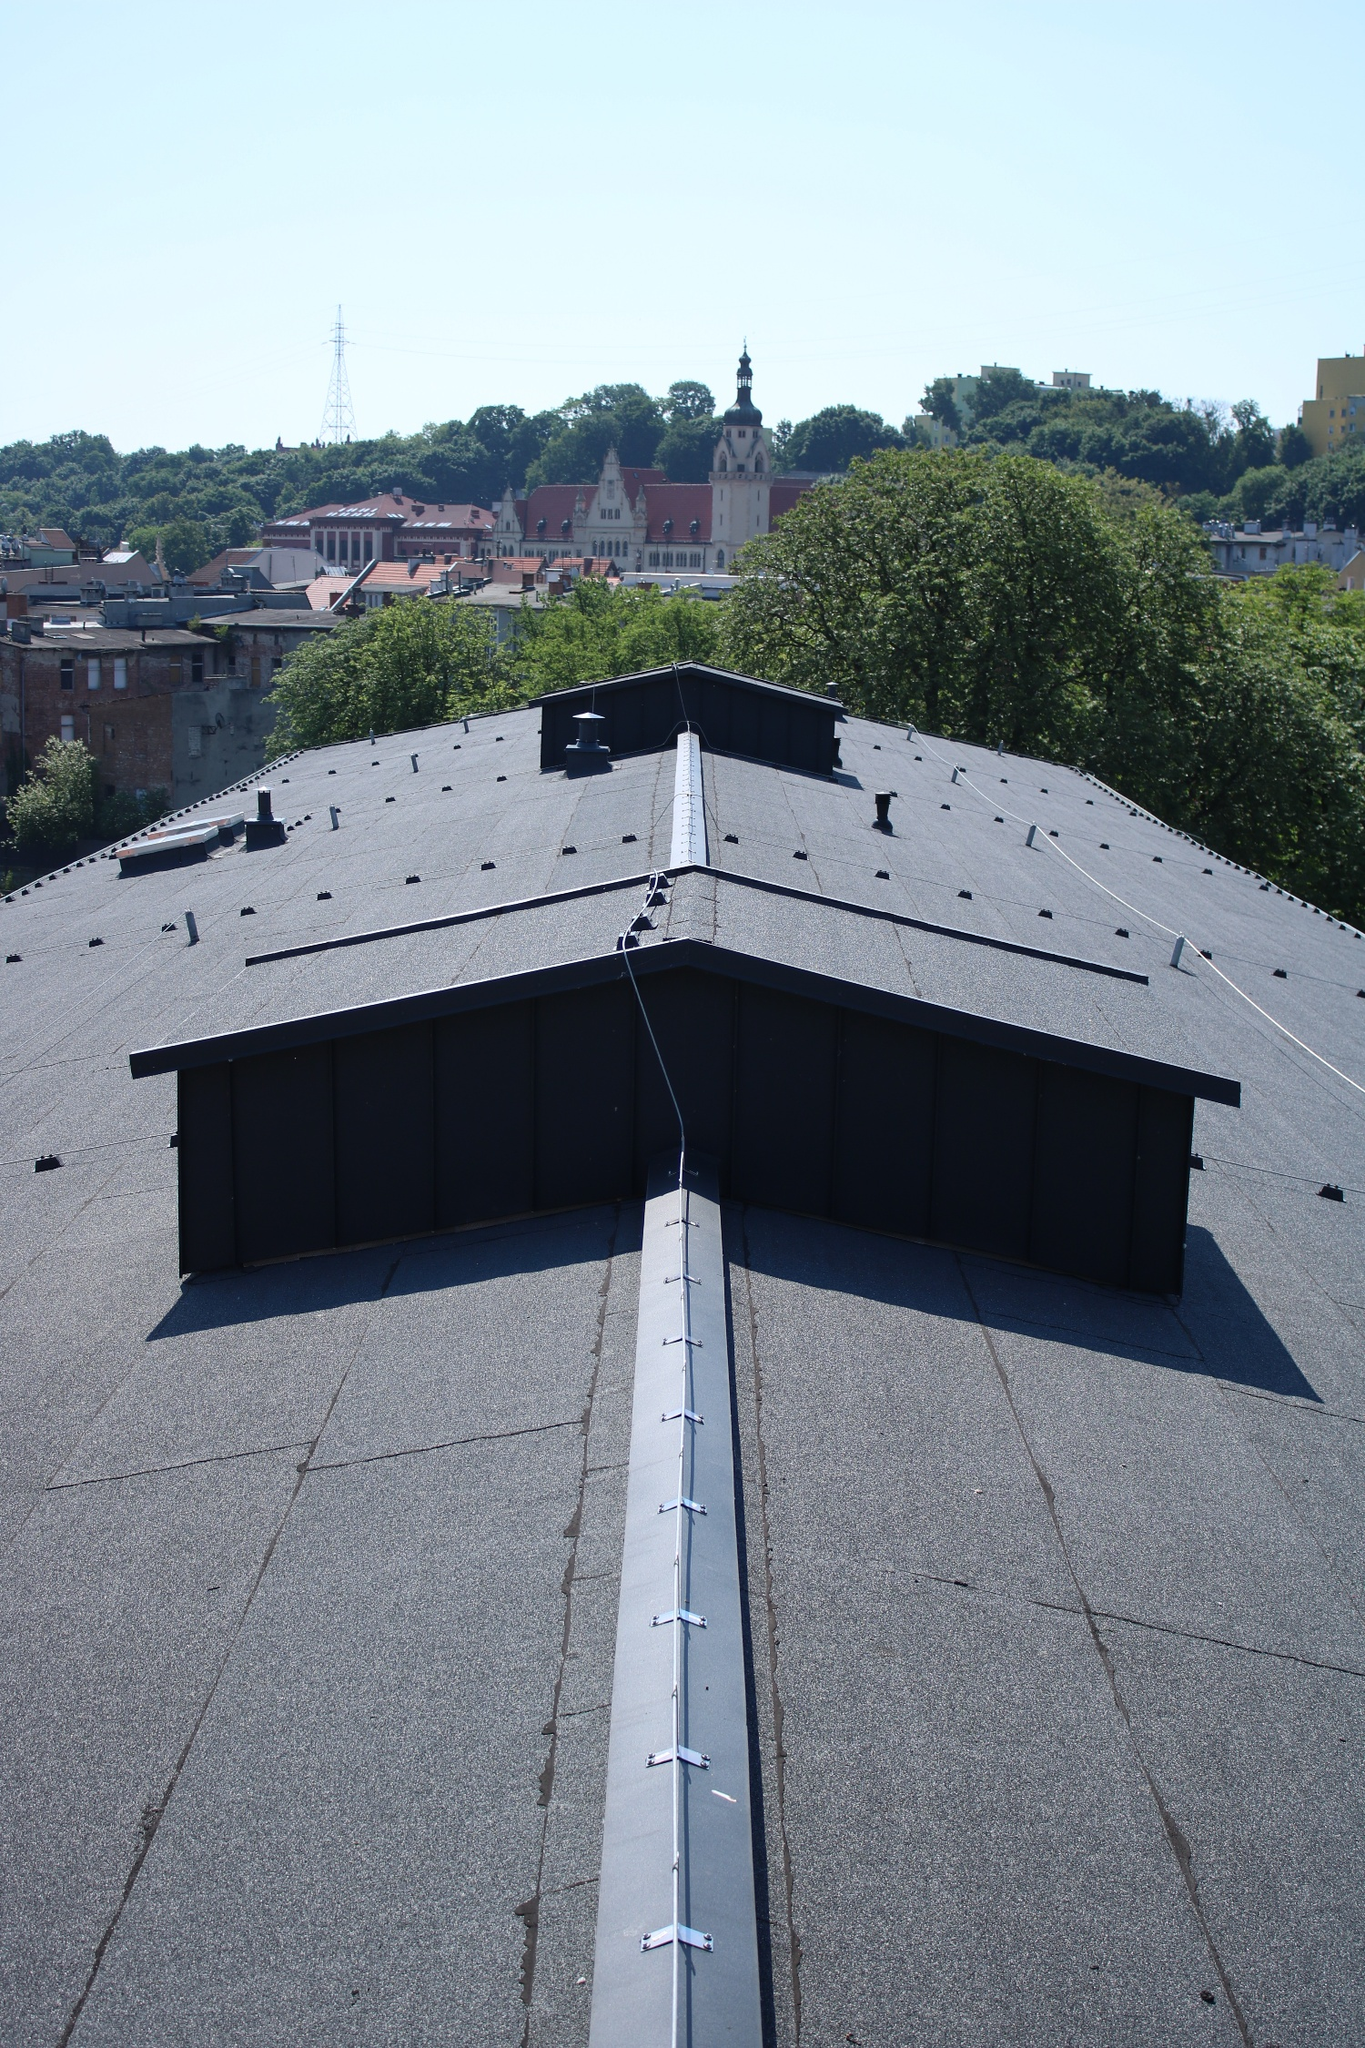Can you describe the main features of this image for me? The photograph showcases an elevated perspective of an urban cityscape, focusing on the rooftop of a building. The roof, predominantly black, features multiple small chimneys and vents enhancing its industrial aesthetic. A distinctive white line runs down the middle of the roof, adding a symmetrical element to the composition. Beyond the roof, a picturesque city unfolds, with buildings of varying architectural styles and heights interspersed with lush green trees. The backdrop includes a clear, azure sky with no clouds, suggesting a bright, sunny day. The vantage point provides a sweeping bird's-eye view, adding depth and scale to the scene. Notable architectural landmarks, possibly with historical significance, are visible in the distance, providing a sense of cultural and geographical context to the image. 